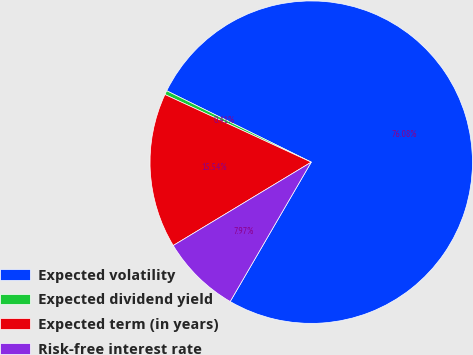Convert chart to OTSL. <chart><loc_0><loc_0><loc_500><loc_500><pie_chart><fcel>Expected volatility<fcel>Expected dividend yield<fcel>Expected term (in years)<fcel>Risk-free interest rate<nl><fcel>76.08%<fcel>0.41%<fcel>15.54%<fcel>7.97%<nl></chart> 